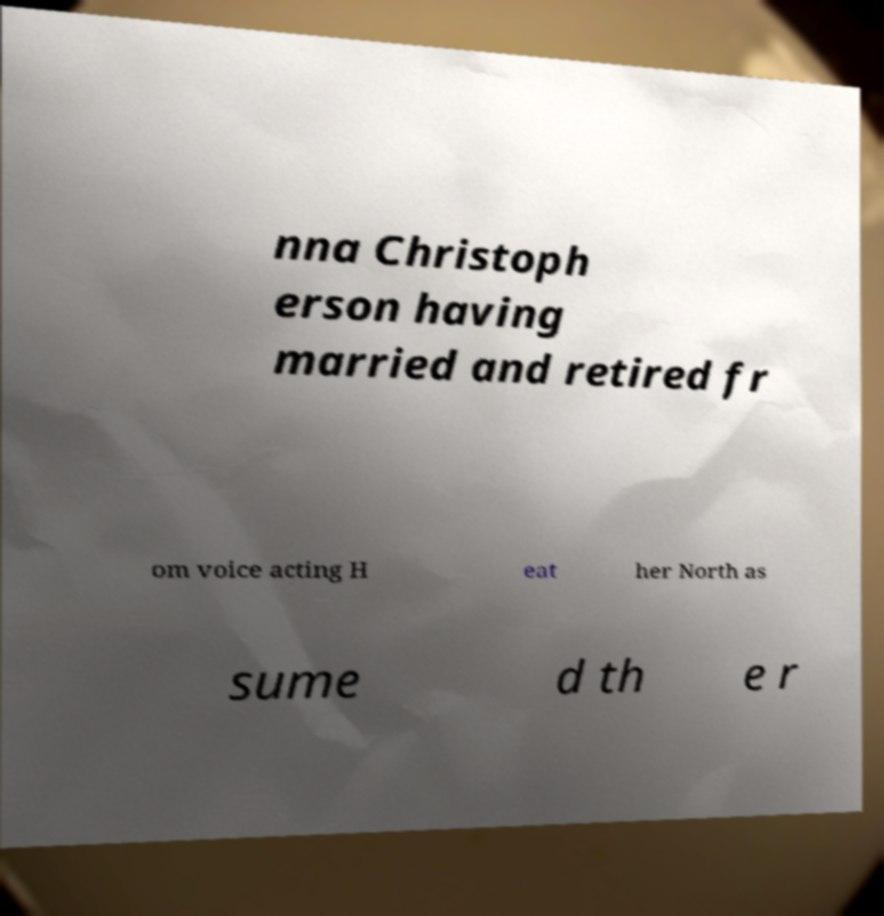Could you extract and type out the text from this image? nna Christoph erson having married and retired fr om voice acting H eat her North as sume d th e r 